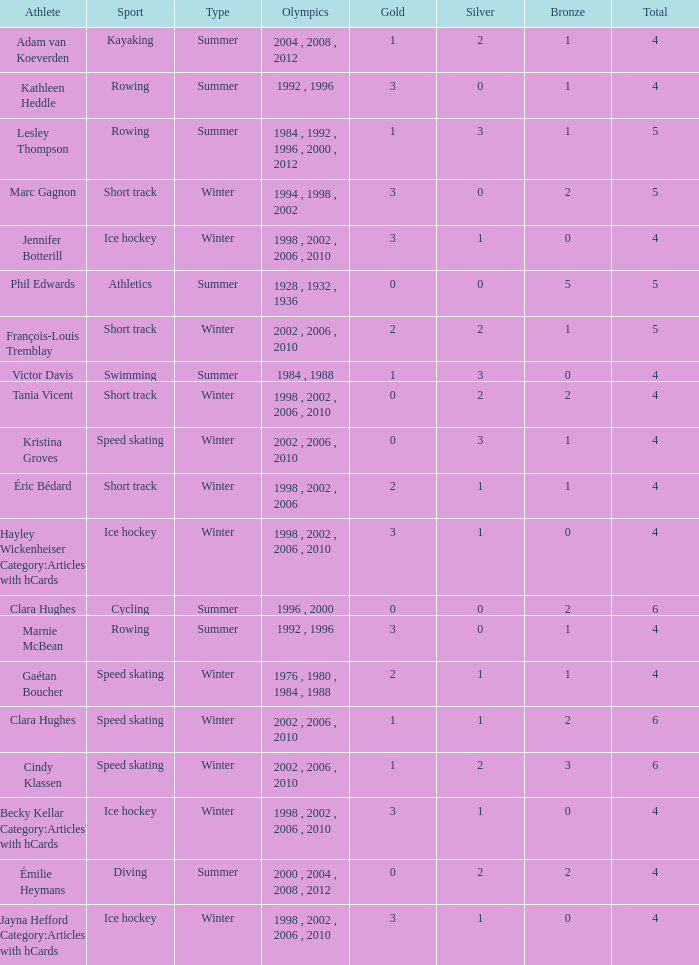What is the lowest number of bronze a short track athlete with 0 gold medals has? 2.0. Can you give me this table as a dict? {'header': ['Athlete', 'Sport', 'Type', 'Olympics', 'Gold', 'Silver', 'Bronze', 'Total'], 'rows': [['Adam van Koeverden', 'Kayaking', 'Summer', '2004 , 2008 , 2012', '1', '2', '1', '4'], ['Kathleen Heddle', 'Rowing', 'Summer', '1992 , 1996', '3', '0', '1', '4'], ['Lesley Thompson', 'Rowing', 'Summer', '1984 , 1992 , 1996 , 2000 , 2012', '1', '3', '1', '5'], ['Marc Gagnon', 'Short track', 'Winter', '1994 , 1998 , 2002', '3', '0', '2', '5'], ['Jennifer Botterill', 'Ice hockey', 'Winter', '1998 , 2002 , 2006 , 2010', '3', '1', '0', '4'], ['Phil Edwards', 'Athletics', 'Summer', '1928 , 1932 , 1936', '0', '0', '5', '5'], ['François-Louis Tremblay', 'Short track', 'Winter', '2002 , 2006 , 2010', '2', '2', '1', '5'], ['Victor Davis', 'Swimming', 'Summer', '1984 , 1988', '1', '3', '0', '4'], ['Tania Vicent', 'Short track', 'Winter', '1998 , 2002 , 2006 , 2010', '0', '2', '2', '4'], ['Kristina Groves', 'Speed skating', 'Winter', '2002 , 2006 , 2010', '0', '3', '1', '4'], ['Éric Bédard', 'Short track', 'Winter', '1998 , 2002 , 2006', '2', '1', '1', '4'], ['Hayley Wickenheiser Category:Articles with hCards', 'Ice hockey', 'Winter', '1998 , 2002 , 2006 , 2010', '3', '1', '0', '4'], ['Clara Hughes', 'Cycling', 'Summer', '1996 , 2000', '0', '0', '2', '6'], ['Marnie McBean', 'Rowing', 'Summer', '1992 , 1996', '3', '0', '1', '4'], ['Gaétan Boucher', 'Speed skating', 'Winter', '1976 , 1980 , 1984 , 1988', '2', '1', '1', '4'], ['Clara Hughes', 'Speed skating', 'Winter', '2002 , 2006 , 2010', '1', '1', '2', '6'], ['Cindy Klassen', 'Speed skating', 'Winter', '2002 , 2006 , 2010', '1', '2', '3', '6'], ['Becky Kellar Category:Articles with hCards', 'Ice hockey', 'Winter', '1998 , 2002 , 2006 , 2010', '3', '1', '0', '4'], ['Émilie Heymans', 'Diving', 'Summer', '2000 , 2004 , 2008 , 2012', '0', '2', '2', '4'], ['Jayna Hefford Category:Articles with hCards', 'Ice hockey', 'Winter', '1998 , 2002 , 2006 , 2010', '3', '1', '0', '4']]} 